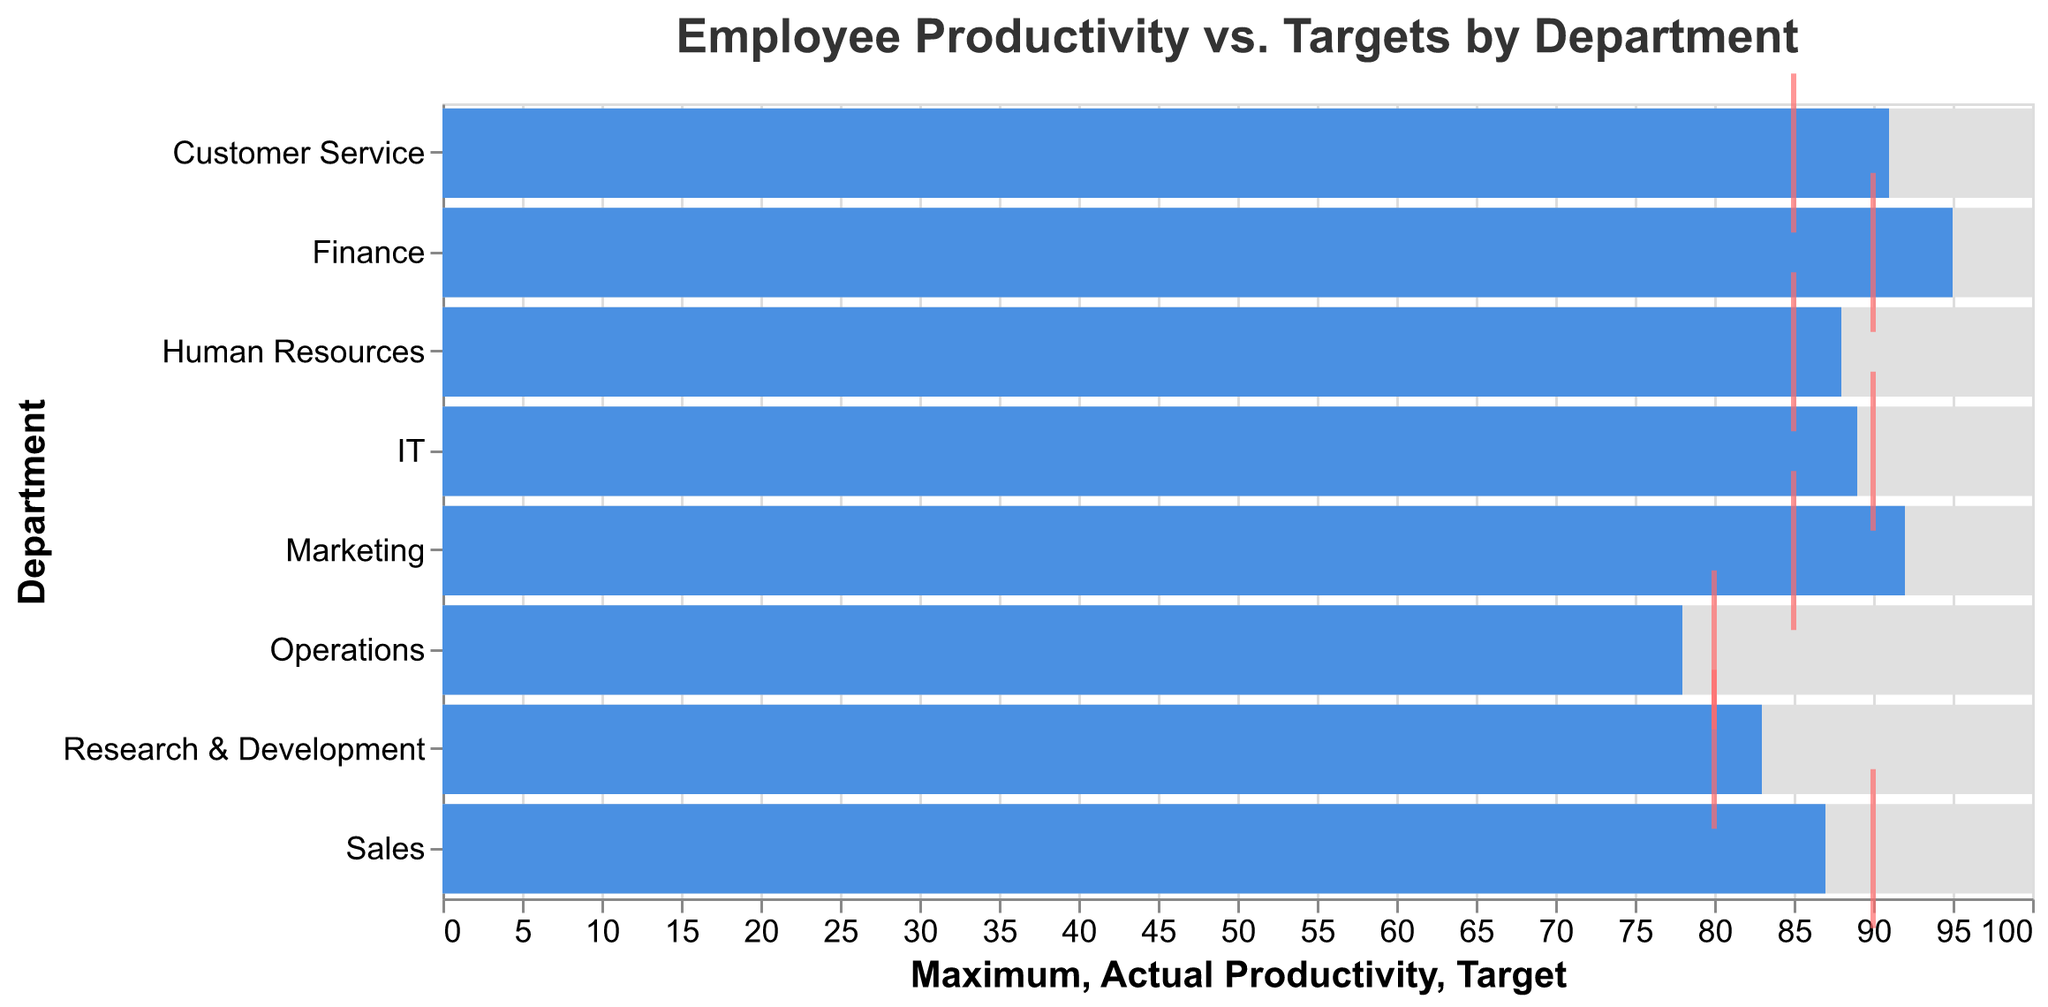What is the title of the chart? The title is usually positioned at the top of the chart and states what the data represents. In this case, it indicates that the chart shows "Employee Productivity vs. Targets by Department."
Answer: Employee Productivity vs. Targets by Department Which department has the highest actual productivity? By looking at the "Actual Productivity" bars, the department with the highest bar will have the highest actual productivity. The "Finance" department has an actual productivity of 95, which is the highest.
Answer: Finance How many departments have reached or exceeded their target productivity? Compare the "Actual Productivity" bars with the "Target" ticks. Departments where the bar extends past or meets the tick have reached or exceeded their targets. These departments are Marketing, Finance, Human Resources, Research & Development, Customer Service.
Answer: 5 Which department has the largest gap between actual productivity and the target? For this, you need to calculate the absolute differences between "Actual Productivity" and "Target" for each department. Operations has the actual productivity of 78 and the target of 80, giving the largest gap of 2.
Answer: Operations What is the average actual productivity across all departments? Add all the actual productivity values and divide by the number of departments. (87 + 92 + 78 + 95 + 88 + 83 + 91 + 89) / 8 = 703 / 8 = 87.875
Answer: 87.875 Which departments have exceeded their targets? Compare the "Actual Productivity" to the "Target." Departments exceeding their target have an "Actual Productivity" bar that goes beyond the "Target" tick. These departments are Marketing, Finance, Human Resources, Research & Development, Customer Service.
Answer: Marketing, Finance, Human Resources, Research & Development, Customer Service How much under the target is the Sales department's actual productivity? Find the difference between the "Target" and the "Actual Productivity" for Sales. The target for Sales is 90, and the actual is 87. The difference is 90 - 87, which is 3.
Answer: 3 Which departments have a target productivity of 85? By examining the "Target" ticks, note the departments whose tick is marked at 85. Marketing, Human Resources, and Customer Service have a target productivity of 85.
Answer: Marketing, Human Resources, Customer Service What is the difference between the highest actual productivity and the lowest actual productivity? Identify the highest and lowest "Actual Productivity" values first. The highest is 95 (Finance) and the lowest is 78 (Operations). The difference is calculated as 95 - 78.
Answer: 17 Do any departments have the same actual productivity and target productivity? Check if any "Actual Productivity" bars match exactly with the "Target" ticks. The IT department has an actual productivity of 89 and a target of 90, which is not matching. There's no department with exact values.
Answer: No 